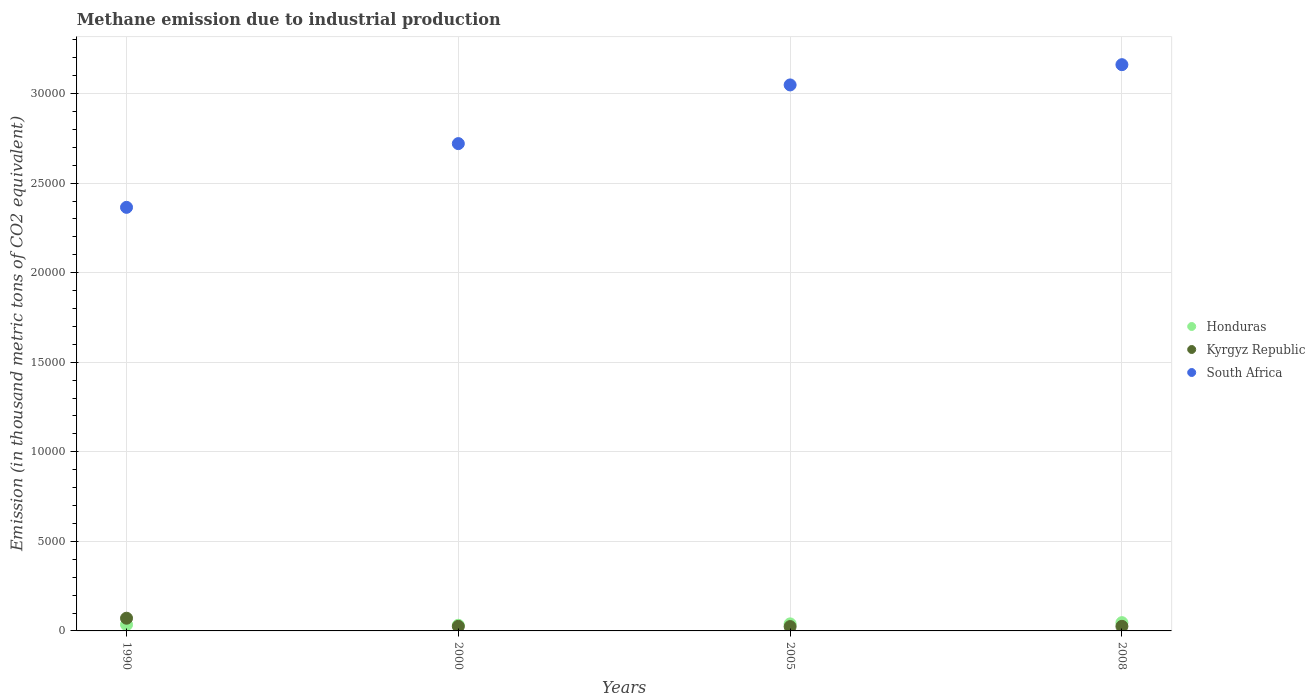How many different coloured dotlines are there?
Provide a succinct answer. 3. Is the number of dotlines equal to the number of legend labels?
Your answer should be very brief. Yes. What is the amount of methane emitted in South Africa in 1990?
Provide a succinct answer. 2.36e+04. Across all years, what is the maximum amount of methane emitted in South Africa?
Your answer should be very brief. 3.16e+04. Across all years, what is the minimum amount of methane emitted in Kyrgyz Republic?
Provide a succinct answer. 242.8. In which year was the amount of methane emitted in Honduras maximum?
Provide a succinct answer. 2008. What is the total amount of methane emitted in Kyrgyz Republic in the graph?
Offer a terse response. 1464. What is the difference between the amount of methane emitted in Kyrgyz Republic in 2000 and that in 2008?
Provide a succinct answer. -0.1. What is the difference between the amount of methane emitted in Honduras in 2005 and the amount of methane emitted in Kyrgyz Republic in 2008?
Ensure brevity in your answer.  137.2. What is the average amount of methane emitted in South Africa per year?
Make the answer very short. 2.82e+04. In the year 2005, what is the difference between the amount of methane emitted in Kyrgyz Republic and amount of methane emitted in South Africa?
Provide a short and direct response. -3.02e+04. What is the ratio of the amount of methane emitted in Honduras in 1990 to that in 2000?
Keep it short and to the point. 1.11. What is the difference between the highest and the second highest amount of methane emitted in Honduras?
Keep it short and to the point. 68.5. What is the difference between the highest and the lowest amount of methane emitted in Kyrgyz Republic?
Ensure brevity in your answer.  466.5. Is the sum of the amount of methane emitted in Kyrgyz Republic in 1990 and 2005 greater than the maximum amount of methane emitted in South Africa across all years?
Ensure brevity in your answer.  No. Is it the case that in every year, the sum of the amount of methane emitted in Kyrgyz Republic and amount of methane emitted in Honduras  is greater than the amount of methane emitted in South Africa?
Give a very brief answer. No. Does the amount of methane emitted in South Africa monotonically increase over the years?
Offer a terse response. Yes. Is the amount of methane emitted in South Africa strictly greater than the amount of methane emitted in Honduras over the years?
Offer a very short reply. Yes. Is the amount of methane emitted in Honduras strictly less than the amount of methane emitted in Kyrgyz Republic over the years?
Provide a succinct answer. No. How many dotlines are there?
Offer a terse response. 3. How many years are there in the graph?
Keep it short and to the point. 4. Does the graph contain any zero values?
Provide a succinct answer. No. Where does the legend appear in the graph?
Your answer should be compact. Center right. What is the title of the graph?
Make the answer very short. Methane emission due to industrial production. What is the label or title of the X-axis?
Offer a very short reply. Years. What is the label or title of the Y-axis?
Give a very brief answer. Emission (in thousand metric tons of CO2 equivalent). What is the Emission (in thousand metric tons of CO2 equivalent) of Honduras in 1990?
Offer a very short reply. 349.7. What is the Emission (in thousand metric tons of CO2 equivalent) in Kyrgyz Republic in 1990?
Provide a succinct answer. 709.3. What is the Emission (in thousand metric tons of CO2 equivalent) of South Africa in 1990?
Offer a terse response. 2.36e+04. What is the Emission (in thousand metric tons of CO2 equivalent) of Honduras in 2000?
Make the answer very short. 315.9. What is the Emission (in thousand metric tons of CO2 equivalent) of Kyrgyz Republic in 2000?
Keep it short and to the point. 255.9. What is the Emission (in thousand metric tons of CO2 equivalent) of South Africa in 2000?
Keep it short and to the point. 2.72e+04. What is the Emission (in thousand metric tons of CO2 equivalent) in Honduras in 2005?
Offer a very short reply. 393.2. What is the Emission (in thousand metric tons of CO2 equivalent) in Kyrgyz Republic in 2005?
Your answer should be compact. 242.8. What is the Emission (in thousand metric tons of CO2 equivalent) of South Africa in 2005?
Your response must be concise. 3.05e+04. What is the Emission (in thousand metric tons of CO2 equivalent) of Honduras in 2008?
Provide a succinct answer. 461.7. What is the Emission (in thousand metric tons of CO2 equivalent) in Kyrgyz Republic in 2008?
Give a very brief answer. 256. What is the Emission (in thousand metric tons of CO2 equivalent) in South Africa in 2008?
Provide a short and direct response. 3.16e+04. Across all years, what is the maximum Emission (in thousand metric tons of CO2 equivalent) of Honduras?
Your answer should be compact. 461.7. Across all years, what is the maximum Emission (in thousand metric tons of CO2 equivalent) of Kyrgyz Republic?
Keep it short and to the point. 709.3. Across all years, what is the maximum Emission (in thousand metric tons of CO2 equivalent) of South Africa?
Keep it short and to the point. 3.16e+04. Across all years, what is the minimum Emission (in thousand metric tons of CO2 equivalent) of Honduras?
Ensure brevity in your answer.  315.9. Across all years, what is the minimum Emission (in thousand metric tons of CO2 equivalent) of Kyrgyz Republic?
Give a very brief answer. 242.8. Across all years, what is the minimum Emission (in thousand metric tons of CO2 equivalent) of South Africa?
Provide a succinct answer. 2.36e+04. What is the total Emission (in thousand metric tons of CO2 equivalent) of Honduras in the graph?
Provide a succinct answer. 1520.5. What is the total Emission (in thousand metric tons of CO2 equivalent) in Kyrgyz Republic in the graph?
Provide a short and direct response. 1464. What is the total Emission (in thousand metric tons of CO2 equivalent) in South Africa in the graph?
Make the answer very short. 1.13e+05. What is the difference between the Emission (in thousand metric tons of CO2 equivalent) in Honduras in 1990 and that in 2000?
Provide a short and direct response. 33.8. What is the difference between the Emission (in thousand metric tons of CO2 equivalent) in Kyrgyz Republic in 1990 and that in 2000?
Make the answer very short. 453.4. What is the difference between the Emission (in thousand metric tons of CO2 equivalent) in South Africa in 1990 and that in 2000?
Your response must be concise. -3558.3. What is the difference between the Emission (in thousand metric tons of CO2 equivalent) of Honduras in 1990 and that in 2005?
Offer a terse response. -43.5. What is the difference between the Emission (in thousand metric tons of CO2 equivalent) in Kyrgyz Republic in 1990 and that in 2005?
Your response must be concise. 466.5. What is the difference between the Emission (in thousand metric tons of CO2 equivalent) in South Africa in 1990 and that in 2005?
Provide a short and direct response. -6834.8. What is the difference between the Emission (in thousand metric tons of CO2 equivalent) of Honduras in 1990 and that in 2008?
Ensure brevity in your answer.  -112. What is the difference between the Emission (in thousand metric tons of CO2 equivalent) in Kyrgyz Republic in 1990 and that in 2008?
Give a very brief answer. 453.3. What is the difference between the Emission (in thousand metric tons of CO2 equivalent) in South Africa in 1990 and that in 2008?
Offer a very short reply. -7965.9. What is the difference between the Emission (in thousand metric tons of CO2 equivalent) in Honduras in 2000 and that in 2005?
Provide a short and direct response. -77.3. What is the difference between the Emission (in thousand metric tons of CO2 equivalent) of South Africa in 2000 and that in 2005?
Your answer should be very brief. -3276.5. What is the difference between the Emission (in thousand metric tons of CO2 equivalent) of Honduras in 2000 and that in 2008?
Provide a succinct answer. -145.8. What is the difference between the Emission (in thousand metric tons of CO2 equivalent) in South Africa in 2000 and that in 2008?
Ensure brevity in your answer.  -4407.6. What is the difference between the Emission (in thousand metric tons of CO2 equivalent) of Honduras in 2005 and that in 2008?
Offer a terse response. -68.5. What is the difference between the Emission (in thousand metric tons of CO2 equivalent) in Kyrgyz Republic in 2005 and that in 2008?
Your answer should be very brief. -13.2. What is the difference between the Emission (in thousand metric tons of CO2 equivalent) of South Africa in 2005 and that in 2008?
Make the answer very short. -1131.1. What is the difference between the Emission (in thousand metric tons of CO2 equivalent) of Honduras in 1990 and the Emission (in thousand metric tons of CO2 equivalent) of Kyrgyz Republic in 2000?
Provide a succinct answer. 93.8. What is the difference between the Emission (in thousand metric tons of CO2 equivalent) in Honduras in 1990 and the Emission (in thousand metric tons of CO2 equivalent) in South Africa in 2000?
Ensure brevity in your answer.  -2.69e+04. What is the difference between the Emission (in thousand metric tons of CO2 equivalent) of Kyrgyz Republic in 1990 and the Emission (in thousand metric tons of CO2 equivalent) of South Africa in 2000?
Keep it short and to the point. -2.65e+04. What is the difference between the Emission (in thousand metric tons of CO2 equivalent) in Honduras in 1990 and the Emission (in thousand metric tons of CO2 equivalent) in Kyrgyz Republic in 2005?
Provide a short and direct response. 106.9. What is the difference between the Emission (in thousand metric tons of CO2 equivalent) of Honduras in 1990 and the Emission (in thousand metric tons of CO2 equivalent) of South Africa in 2005?
Your response must be concise. -3.01e+04. What is the difference between the Emission (in thousand metric tons of CO2 equivalent) in Kyrgyz Republic in 1990 and the Emission (in thousand metric tons of CO2 equivalent) in South Africa in 2005?
Your answer should be compact. -2.98e+04. What is the difference between the Emission (in thousand metric tons of CO2 equivalent) in Honduras in 1990 and the Emission (in thousand metric tons of CO2 equivalent) in Kyrgyz Republic in 2008?
Provide a short and direct response. 93.7. What is the difference between the Emission (in thousand metric tons of CO2 equivalent) of Honduras in 1990 and the Emission (in thousand metric tons of CO2 equivalent) of South Africa in 2008?
Give a very brief answer. -3.13e+04. What is the difference between the Emission (in thousand metric tons of CO2 equivalent) of Kyrgyz Republic in 1990 and the Emission (in thousand metric tons of CO2 equivalent) of South Africa in 2008?
Provide a short and direct response. -3.09e+04. What is the difference between the Emission (in thousand metric tons of CO2 equivalent) of Honduras in 2000 and the Emission (in thousand metric tons of CO2 equivalent) of Kyrgyz Republic in 2005?
Provide a short and direct response. 73.1. What is the difference between the Emission (in thousand metric tons of CO2 equivalent) of Honduras in 2000 and the Emission (in thousand metric tons of CO2 equivalent) of South Africa in 2005?
Offer a terse response. -3.02e+04. What is the difference between the Emission (in thousand metric tons of CO2 equivalent) of Kyrgyz Republic in 2000 and the Emission (in thousand metric tons of CO2 equivalent) of South Africa in 2005?
Provide a short and direct response. -3.02e+04. What is the difference between the Emission (in thousand metric tons of CO2 equivalent) in Honduras in 2000 and the Emission (in thousand metric tons of CO2 equivalent) in Kyrgyz Republic in 2008?
Your answer should be very brief. 59.9. What is the difference between the Emission (in thousand metric tons of CO2 equivalent) of Honduras in 2000 and the Emission (in thousand metric tons of CO2 equivalent) of South Africa in 2008?
Provide a short and direct response. -3.13e+04. What is the difference between the Emission (in thousand metric tons of CO2 equivalent) in Kyrgyz Republic in 2000 and the Emission (in thousand metric tons of CO2 equivalent) in South Africa in 2008?
Your response must be concise. -3.14e+04. What is the difference between the Emission (in thousand metric tons of CO2 equivalent) in Honduras in 2005 and the Emission (in thousand metric tons of CO2 equivalent) in Kyrgyz Republic in 2008?
Give a very brief answer. 137.2. What is the difference between the Emission (in thousand metric tons of CO2 equivalent) of Honduras in 2005 and the Emission (in thousand metric tons of CO2 equivalent) of South Africa in 2008?
Your answer should be compact. -3.12e+04. What is the difference between the Emission (in thousand metric tons of CO2 equivalent) in Kyrgyz Republic in 2005 and the Emission (in thousand metric tons of CO2 equivalent) in South Africa in 2008?
Keep it short and to the point. -3.14e+04. What is the average Emission (in thousand metric tons of CO2 equivalent) in Honduras per year?
Offer a terse response. 380.12. What is the average Emission (in thousand metric tons of CO2 equivalent) of Kyrgyz Republic per year?
Offer a terse response. 366. What is the average Emission (in thousand metric tons of CO2 equivalent) in South Africa per year?
Provide a short and direct response. 2.82e+04. In the year 1990, what is the difference between the Emission (in thousand metric tons of CO2 equivalent) of Honduras and Emission (in thousand metric tons of CO2 equivalent) of Kyrgyz Republic?
Your answer should be very brief. -359.6. In the year 1990, what is the difference between the Emission (in thousand metric tons of CO2 equivalent) in Honduras and Emission (in thousand metric tons of CO2 equivalent) in South Africa?
Provide a short and direct response. -2.33e+04. In the year 1990, what is the difference between the Emission (in thousand metric tons of CO2 equivalent) in Kyrgyz Republic and Emission (in thousand metric tons of CO2 equivalent) in South Africa?
Your answer should be compact. -2.29e+04. In the year 2000, what is the difference between the Emission (in thousand metric tons of CO2 equivalent) in Honduras and Emission (in thousand metric tons of CO2 equivalent) in Kyrgyz Republic?
Your answer should be very brief. 60. In the year 2000, what is the difference between the Emission (in thousand metric tons of CO2 equivalent) in Honduras and Emission (in thousand metric tons of CO2 equivalent) in South Africa?
Provide a succinct answer. -2.69e+04. In the year 2000, what is the difference between the Emission (in thousand metric tons of CO2 equivalent) of Kyrgyz Republic and Emission (in thousand metric tons of CO2 equivalent) of South Africa?
Your answer should be very brief. -2.70e+04. In the year 2005, what is the difference between the Emission (in thousand metric tons of CO2 equivalent) of Honduras and Emission (in thousand metric tons of CO2 equivalent) of Kyrgyz Republic?
Ensure brevity in your answer.  150.4. In the year 2005, what is the difference between the Emission (in thousand metric tons of CO2 equivalent) of Honduras and Emission (in thousand metric tons of CO2 equivalent) of South Africa?
Offer a very short reply. -3.01e+04. In the year 2005, what is the difference between the Emission (in thousand metric tons of CO2 equivalent) of Kyrgyz Republic and Emission (in thousand metric tons of CO2 equivalent) of South Africa?
Offer a very short reply. -3.02e+04. In the year 2008, what is the difference between the Emission (in thousand metric tons of CO2 equivalent) in Honduras and Emission (in thousand metric tons of CO2 equivalent) in Kyrgyz Republic?
Your response must be concise. 205.7. In the year 2008, what is the difference between the Emission (in thousand metric tons of CO2 equivalent) of Honduras and Emission (in thousand metric tons of CO2 equivalent) of South Africa?
Offer a very short reply. -3.12e+04. In the year 2008, what is the difference between the Emission (in thousand metric tons of CO2 equivalent) of Kyrgyz Republic and Emission (in thousand metric tons of CO2 equivalent) of South Africa?
Offer a very short reply. -3.14e+04. What is the ratio of the Emission (in thousand metric tons of CO2 equivalent) of Honduras in 1990 to that in 2000?
Provide a succinct answer. 1.11. What is the ratio of the Emission (in thousand metric tons of CO2 equivalent) of Kyrgyz Republic in 1990 to that in 2000?
Your answer should be very brief. 2.77. What is the ratio of the Emission (in thousand metric tons of CO2 equivalent) in South Africa in 1990 to that in 2000?
Offer a terse response. 0.87. What is the ratio of the Emission (in thousand metric tons of CO2 equivalent) of Honduras in 1990 to that in 2005?
Your answer should be very brief. 0.89. What is the ratio of the Emission (in thousand metric tons of CO2 equivalent) in Kyrgyz Republic in 1990 to that in 2005?
Provide a succinct answer. 2.92. What is the ratio of the Emission (in thousand metric tons of CO2 equivalent) in South Africa in 1990 to that in 2005?
Your answer should be compact. 0.78. What is the ratio of the Emission (in thousand metric tons of CO2 equivalent) of Honduras in 1990 to that in 2008?
Provide a short and direct response. 0.76. What is the ratio of the Emission (in thousand metric tons of CO2 equivalent) of Kyrgyz Republic in 1990 to that in 2008?
Your answer should be compact. 2.77. What is the ratio of the Emission (in thousand metric tons of CO2 equivalent) in South Africa in 1990 to that in 2008?
Ensure brevity in your answer.  0.75. What is the ratio of the Emission (in thousand metric tons of CO2 equivalent) in Honduras in 2000 to that in 2005?
Your response must be concise. 0.8. What is the ratio of the Emission (in thousand metric tons of CO2 equivalent) in Kyrgyz Republic in 2000 to that in 2005?
Offer a very short reply. 1.05. What is the ratio of the Emission (in thousand metric tons of CO2 equivalent) in South Africa in 2000 to that in 2005?
Your answer should be compact. 0.89. What is the ratio of the Emission (in thousand metric tons of CO2 equivalent) in Honduras in 2000 to that in 2008?
Give a very brief answer. 0.68. What is the ratio of the Emission (in thousand metric tons of CO2 equivalent) of Kyrgyz Republic in 2000 to that in 2008?
Offer a terse response. 1. What is the ratio of the Emission (in thousand metric tons of CO2 equivalent) in South Africa in 2000 to that in 2008?
Your answer should be compact. 0.86. What is the ratio of the Emission (in thousand metric tons of CO2 equivalent) of Honduras in 2005 to that in 2008?
Make the answer very short. 0.85. What is the ratio of the Emission (in thousand metric tons of CO2 equivalent) of Kyrgyz Republic in 2005 to that in 2008?
Provide a succinct answer. 0.95. What is the ratio of the Emission (in thousand metric tons of CO2 equivalent) in South Africa in 2005 to that in 2008?
Give a very brief answer. 0.96. What is the difference between the highest and the second highest Emission (in thousand metric tons of CO2 equivalent) in Honduras?
Offer a terse response. 68.5. What is the difference between the highest and the second highest Emission (in thousand metric tons of CO2 equivalent) of Kyrgyz Republic?
Offer a very short reply. 453.3. What is the difference between the highest and the second highest Emission (in thousand metric tons of CO2 equivalent) of South Africa?
Give a very brief answer. 1131.1. What is the difference between the highest and the lowest Emission (in thousand metric tons of CO2 equivalent) in Honduras?
Offer a very short reply. 145.8. What is the difference between the highest and the lowest Emission (in thousand metric tons of CO2 equivalent) in Kyrgyz Republic?
Offer a very short reply. 466.5. What is the difference between the highest and the lowest Emission (in thousand metric tons of CO2 equivalent) in South Africa?
Keep it short and to the point. 7965.9. 